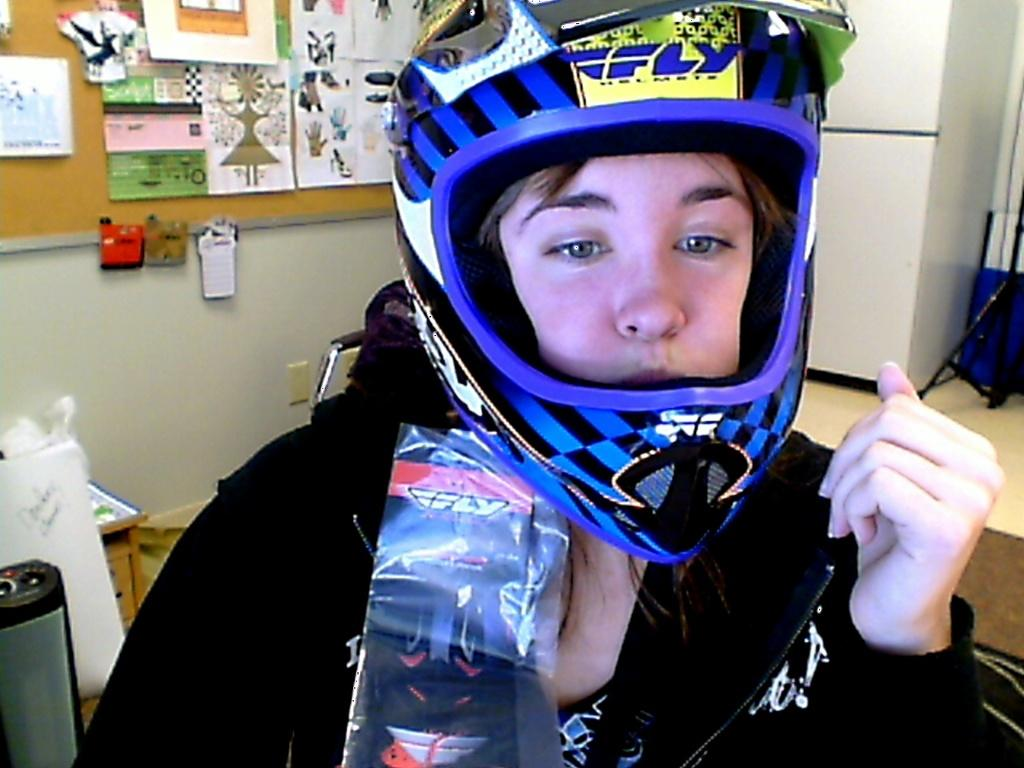What is the person in the image wearing on their head? The person in the image is wearing a helmet. What can be seen in the image that might be used for support or display? There is a stand and a board with posters in the image. What type of seating is present in the image? There is a chair in the image. How are the posters displayed in the image? The posters are displayed on a board that is attached to a wall. What other objects can be seen in the image? There are other objects visible in the image, but their specific details are not mentioned in the provided facts. Can you touch the word "hello" in the image? There is no mention of the word "hello" in the image, so it cannot be touched. 